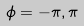Convert formula to latex. <formula><loc_0><loc_0><loc_500><loc_500>\phi = - \pi , \pi</formula> 